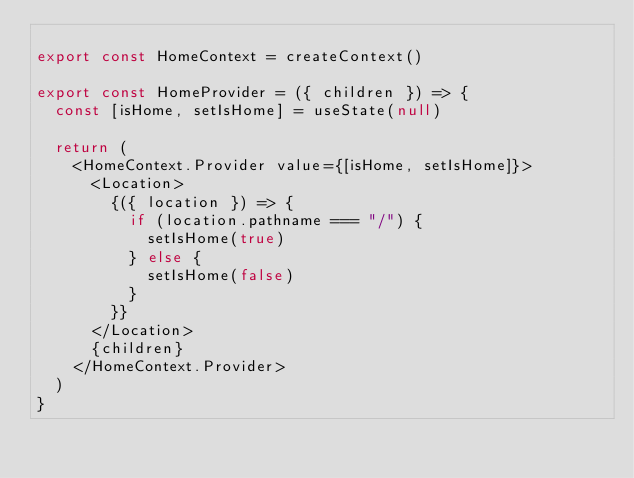Convert code to text. <code><loc_0><loc_0><loc_500><loc_500><_JavaScript_>
export const HomeContext = createContext()

export const HomeProvider = ({ children }) => {
  const [isHome, setIsHome] = useState(null)

  return (
    <HomeContext.Provider value={[isHome, setIsHome]}>
      <Location>
        {({ location }) => {
          if (location.pathname === "/") {
            setIsHome(true)
          } else {
            setIsHome(false)
          }
        }}
      </Location>
      {children}
    </HomeContext.Provider>
  )
}
</code> 